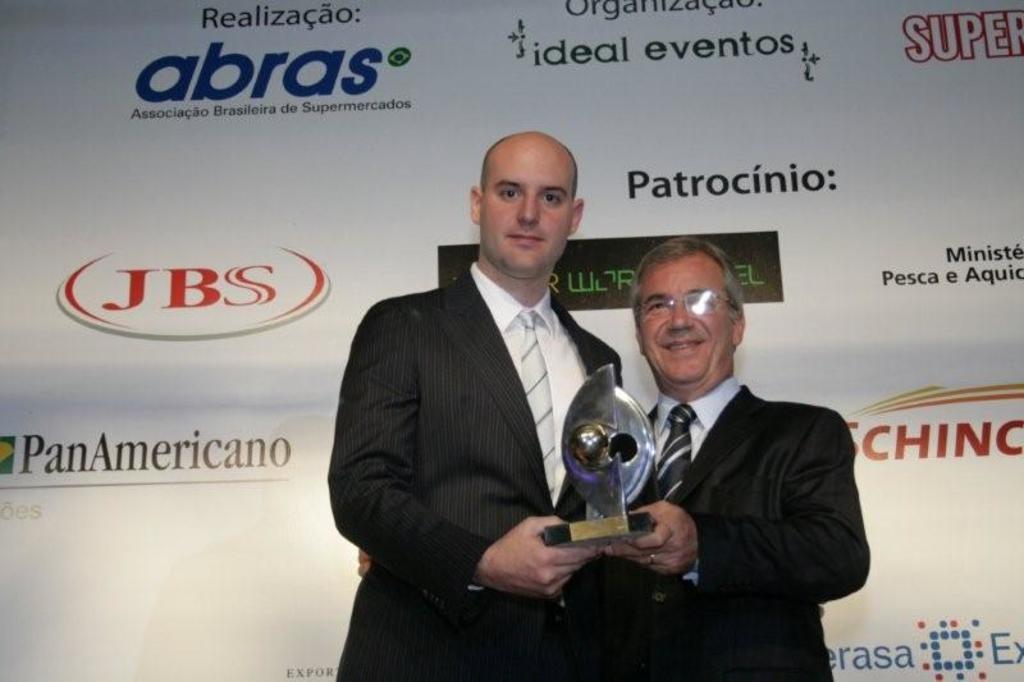Could you give a brief overview of what you see in this image? In the image there are two men in black suits holding a award standing in front of the white banner. 